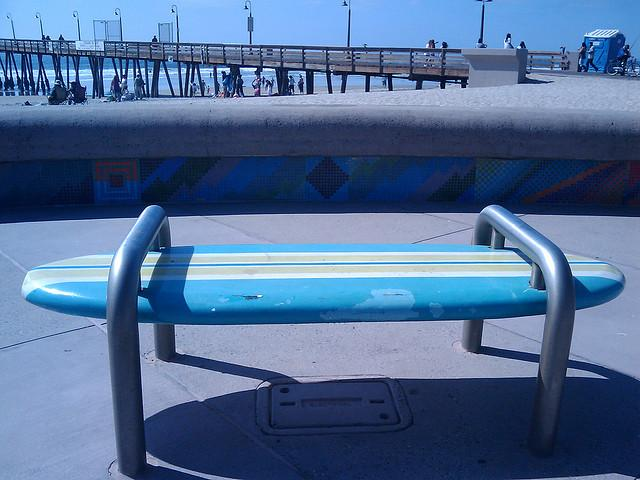What are the bars touching in the foreground?

Choices:
A) baby
B) apple
C) surf board
D) cow surf board 